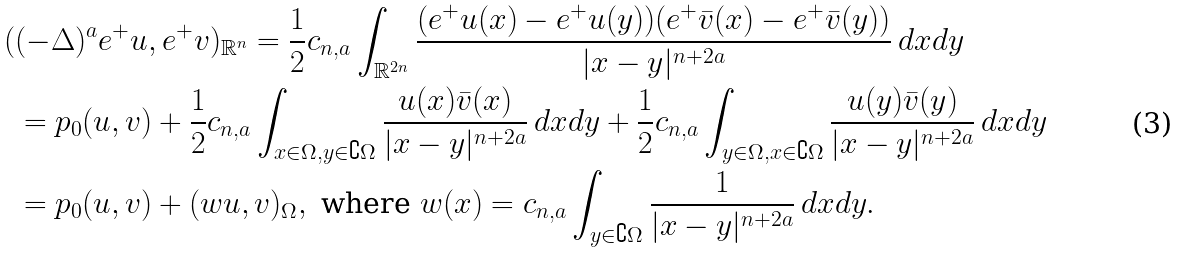<formula> <loc_0><loc_0><loc_500><loc_500>( & ( - \Delta ) ^ { a } e ^ { + } u , e ^ { + } v ) _ { { \mathbb { R } } ^ { n } } = \frac { 1 } { 2 } { c _ { n , a } } \int _ { { \mathbb { R } } ^ { 2 n } } \frac { ( e ^ { + } u ( x ) - e ^ { + } u ( y ) ) ( e ^ { + } \bar { v } ( x ) - e ^ { + } \bar { v } ( y ) ) } { | x - y | ^ { n + 2 a } } \, d x d y \\ & = p _ { 0 } ( u , v ) + \frac { 1 } { 2 } { c _ { n , a } } \int _ { x \in \Omega , y \in \complement \Omega } \frac { u ( x ) \bar { v } ( x ) } { | x - y | ^ { n + 2 a } } \, d x d y + \frac { 1 } { 2 } { c _ { n , a } } \int _ { y \in \Omega , x \in \complement \Omega } \frac { u ( y ) \bar { v } ( y ) } { | x - y | ^ { n + 2 a } } \, d x d y \\ & = p _ { 0 } ( u , v ) + ( w u , v ) _ { \Omega } , \text { where } w ( x ) = c _ { n , a } \int _ { y \in \complement \Omega } \frac { 1 } { | x - y | ^ { n + 2 a } } \, d x d y .</formula> 